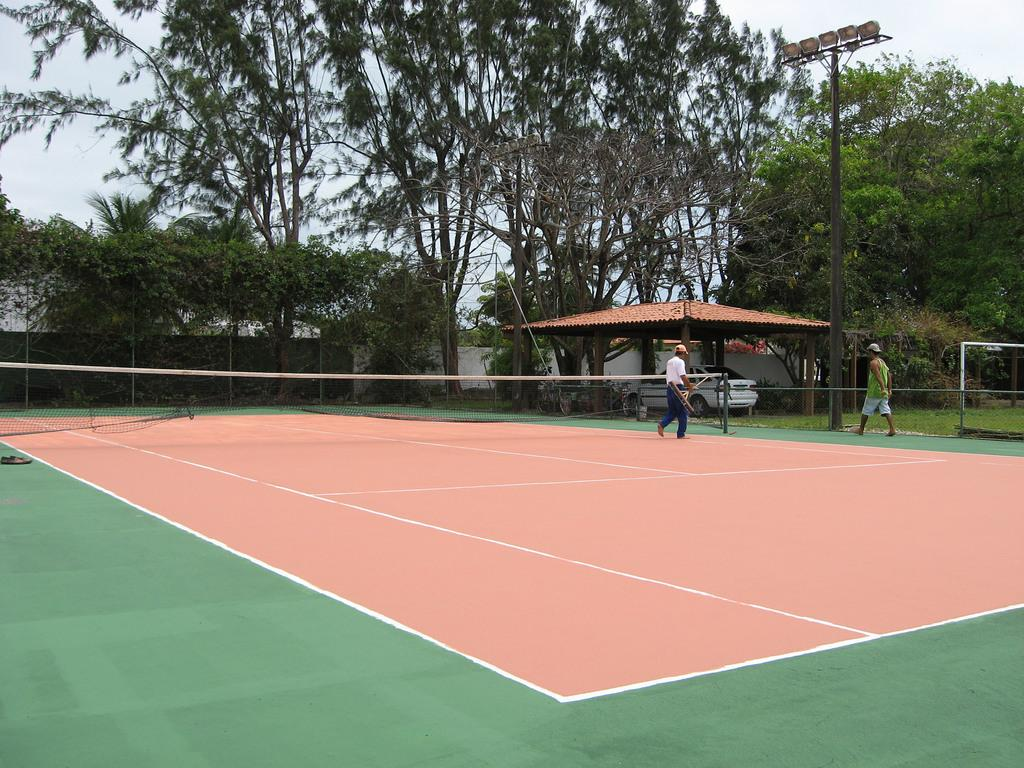What are the two persons in the image doing? The two persons in the image are walking. What can be seen in the background of the image? There is a white car, green trees, and a light pole in the background of the image. What is the color of the sky in the image? The sky is visible in the image and appears to be white. How many sheep are visible in the image? There are no sheep present in the image. Is there a parcel being delivered by a jellyfish in the image? There are no jellyfish or parcels present in the image. 